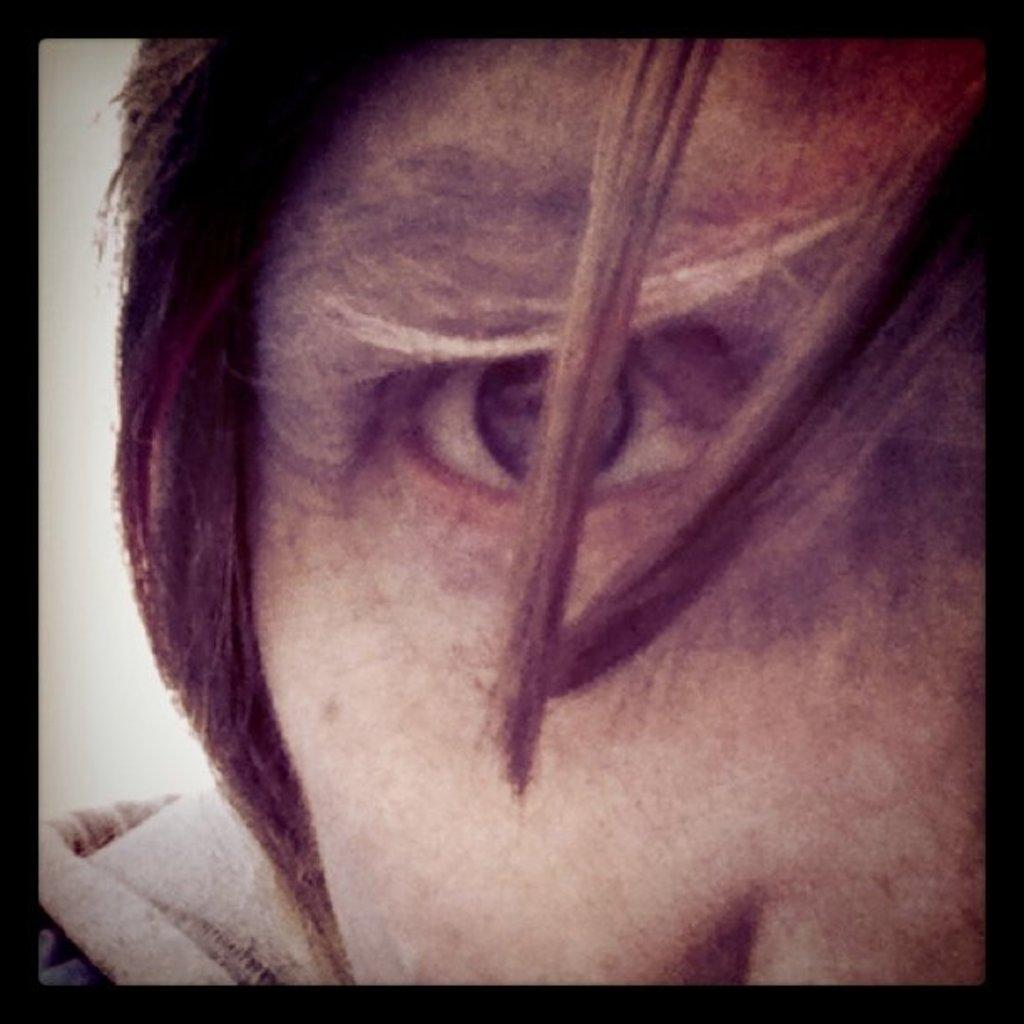What is the main subject of the image? The main subject of the image is a person's face. Can you describe any specific features of the image? Yes, there are black color boundaries in the image. What type of scissors can be seen cutting the person's hair in the image? There are no scissors or hair visible in the image; it only features a person's face with black color boundaries. 